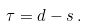Convert formula to latex. <formula><loc_0><loc_0><loc_500><loc_500>\tau = d - s \, .</formula> 